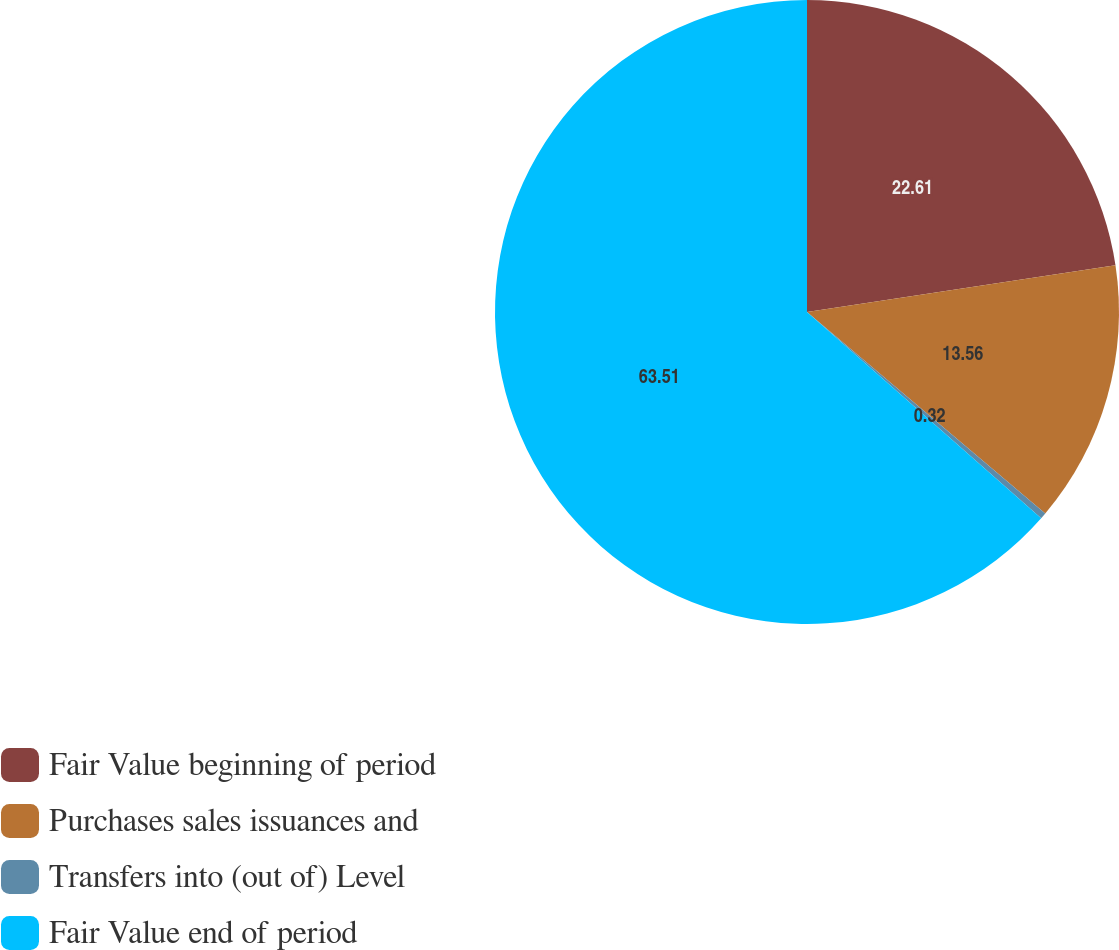<chart> <loc_0><loc_0><loc_500><loc_500><pie_chart><fcel>Fair Value beginning of period<fcel>Purchases sales issuances and<fcel>Transfers into (out of) Level<fcel>Fair Value end of period<nl><fcel>22.61%<fcel>13.56%<fcel>0.32%<fcel>63.51%<nl></chart> 